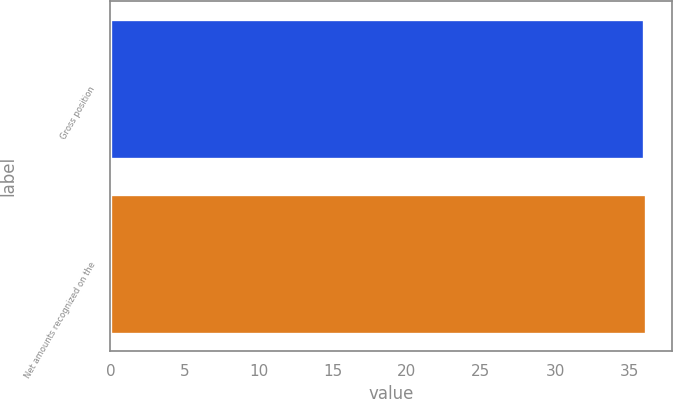Convert chart. <chart><loc_0><loc_0><loc_500><loc_500><bar_chart><fcel>Gross position<fcel>Net amounts recognized on the<nl><fcel>36<fcel>36.1<nl></chart> 